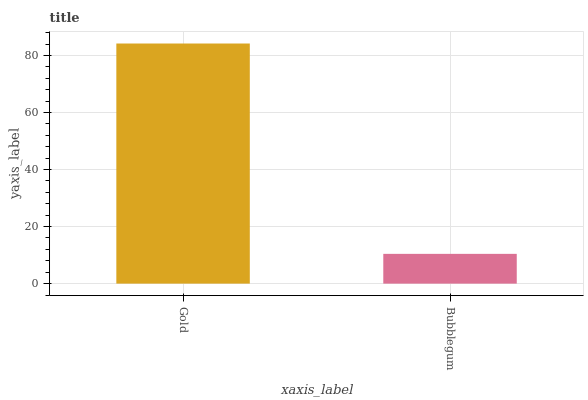Is Bubblegum the minimum?
Answer yes or no. Yes. Is Gold the maximum?
Answer yes or no. Yes. Is Bubblegum the maximum?
Answer yes or no. No. Is Gold greater than Bubblegum?
Answer yes or no. Yes. Is Bubblegum less than Gold?
Answer yes or no. Yes. Is Bubblegum greater than Gold?
Answer yes or no. No. Is Gold less than Bubblegum?
Answer yes or no. No. Is Gold the high median?
Answer yes or no. Yes. Is Bubblegum the low median?
Answer yes or no. Yes. Is Bubblegum the high median?
Answer yes or no. No. Is Gold the low median?
Answer yes or no. No. 